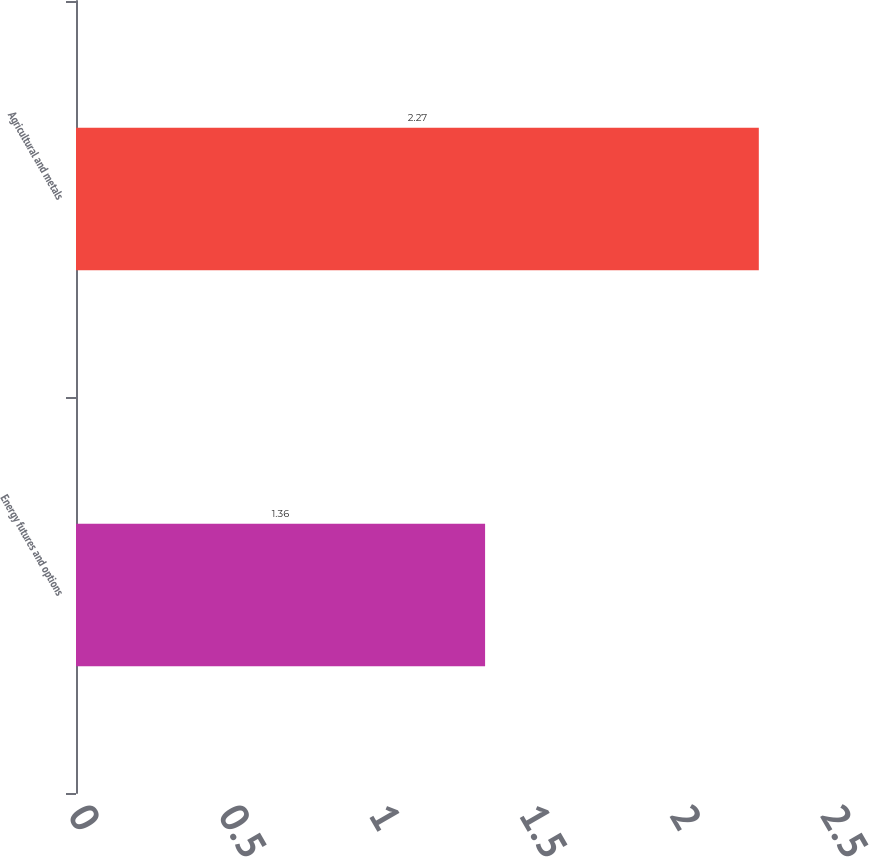Convert chart to OTSL. <chart><loc_0><loc_0><loc_500><loc_500><bar_chart><fcel>Energy futures and options<fcel>Agricultural and metals<nl><fcel>1.36<fcel>2.27<nl></chart> 